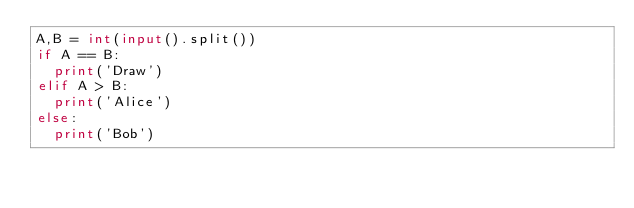<code> <loc_0><loc_0><loc_500><loc_500><_Python_>A,B = int(input().split())
if A == B:
  print('Draw')
elif A > B:
  print('Alice')
else:
  print('Bob')</code> 